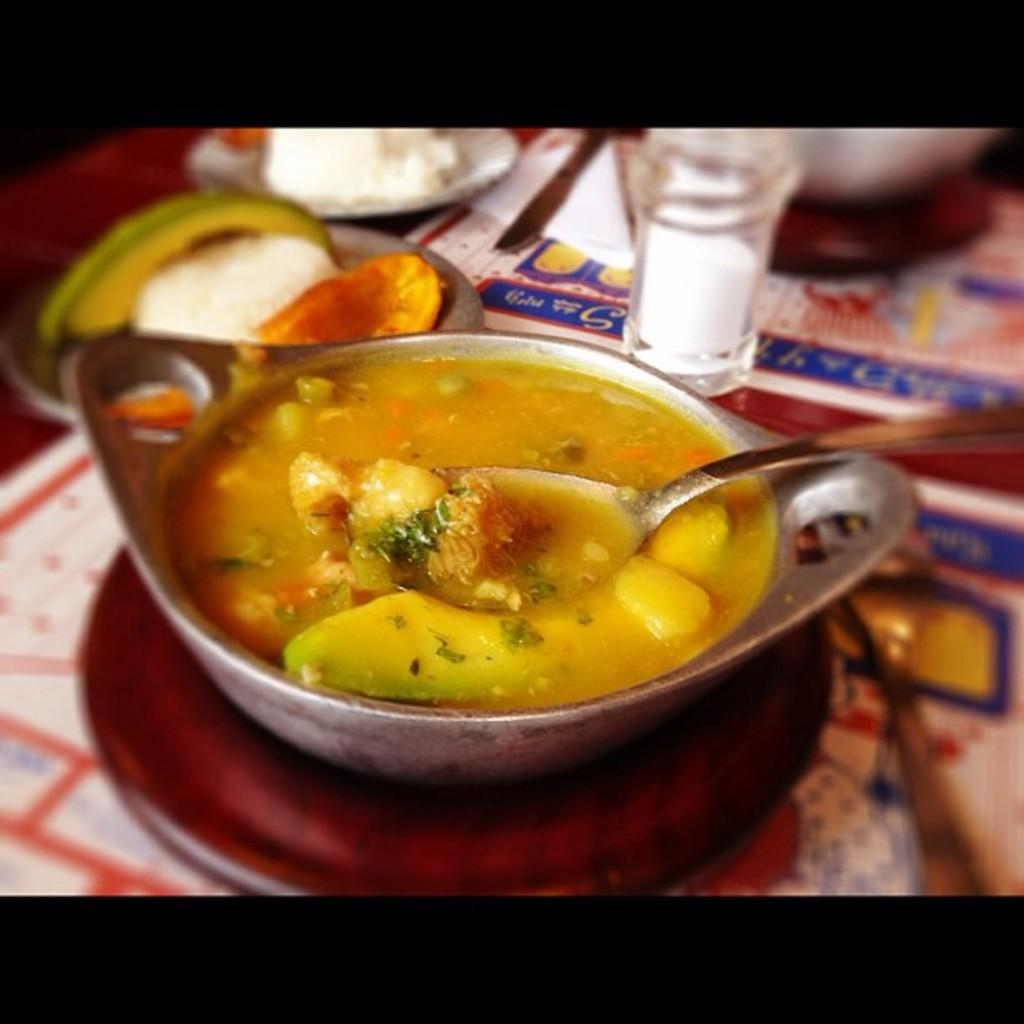What is the main object in the image? There is a bowl in the image. What utensil is present in the image? There is a spoon in the image. What container is visible in the image? There is a jar in the image. What are the flat objects in the image used for? There are plates in the image, which are used for serving food. What sharp object is present in the image? There is a knife in the image. What type of paper is present in the image? There is tissue paper in the image. What type of items are present in the bowl and jar? There are food items in the image. What other objects can be seen in the image? There are other objects in the image. On what surface are all these items placed? All of these items are placed on a surface. What is the title of the book that is being read in the image? There is no book or reading activity present in the image. 